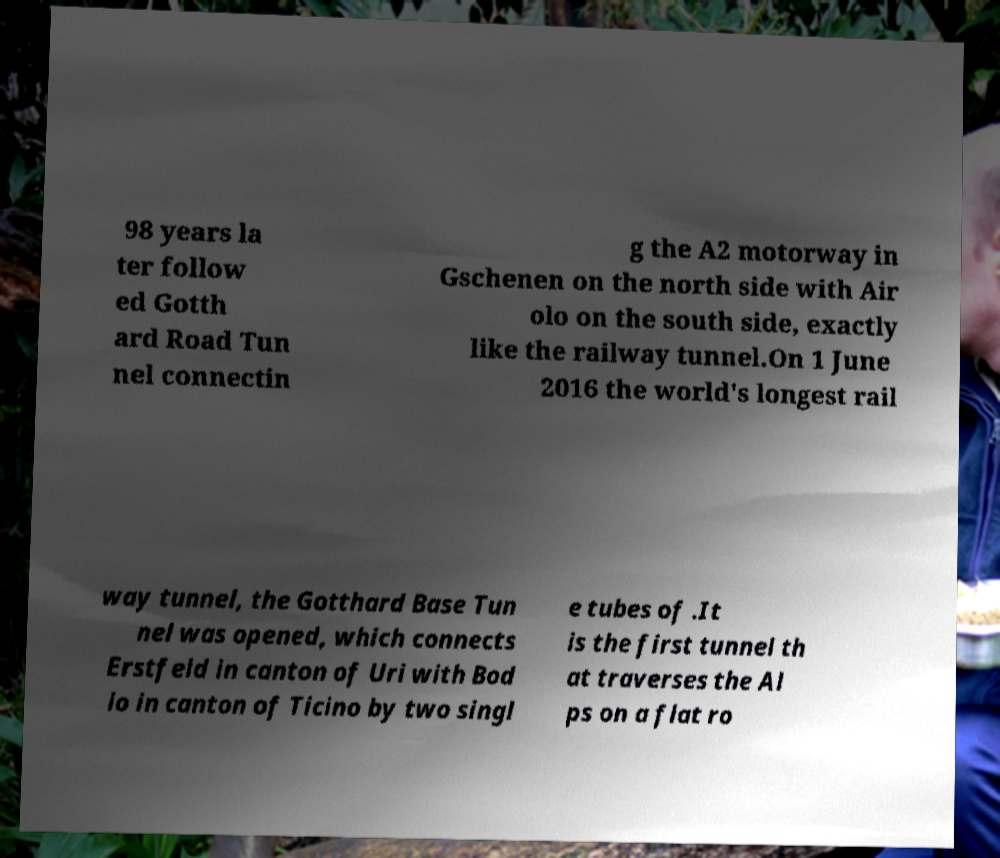For documentation purposes, I need the text within this image transcribed. Could you provide that? 98 years la ter follow ed Gotth ard Road Tun nel connectin g the A2 motorway in Gschenen on the north side with Air olo on the south side, exactly like the railway tunnel.On 1 June 2016 the world's longest rail way tunnel, the Gotthard Base Tun nel was opened, which connects Erstfeld in canton of Uri with Bod io in canton of Ticino by two singl e tubes of .It is the first tunnel th at traverses the Al ps on a flat ro 